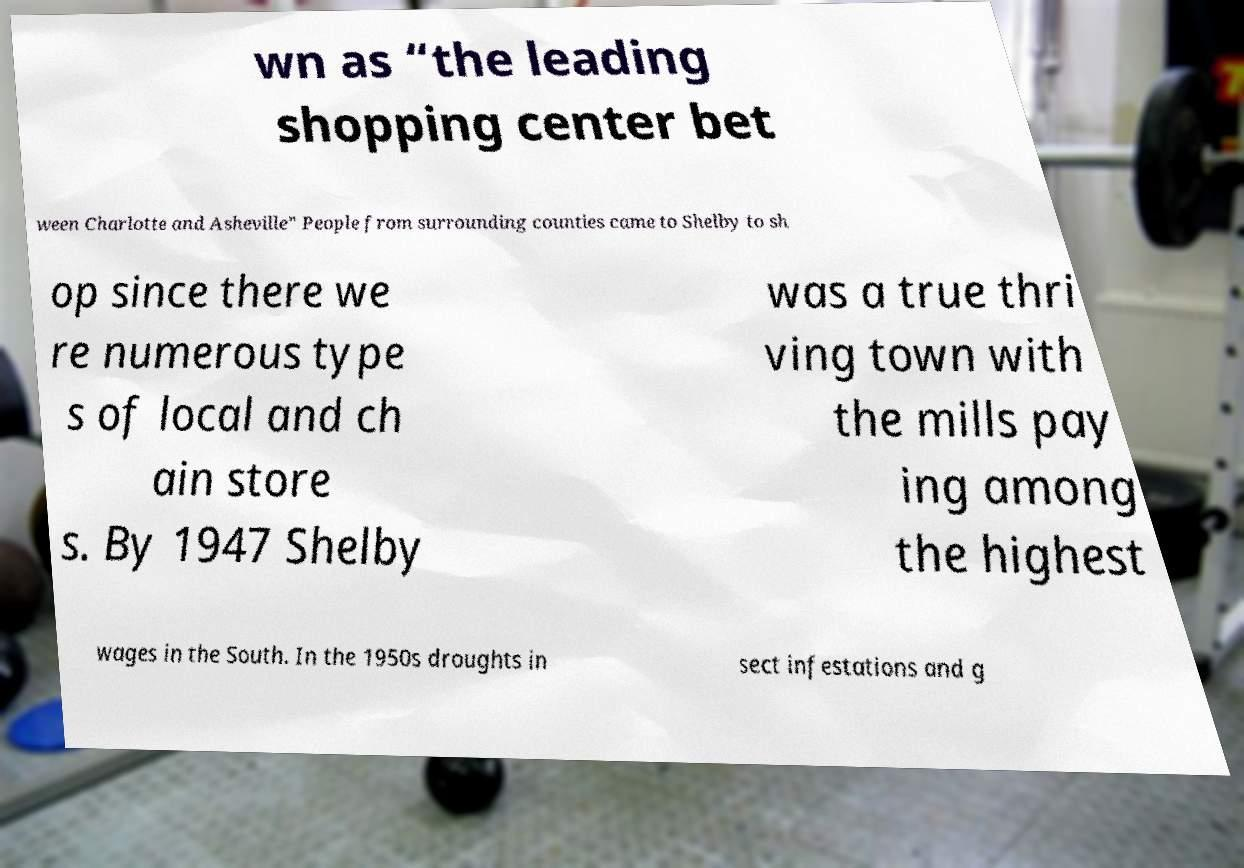Please identify and transcribe the text found in this image. wn as “the leading shopping center bet ween Charlotte and Asheville” People from surrounding counties came to Shelby to sh op since there we re numerous type s of local and ch ain store s. By 1947 Shelby was a true thri ving town with the mills pay ing among the highest wages in the South. In the 1950s droughts in sect infestations and g 